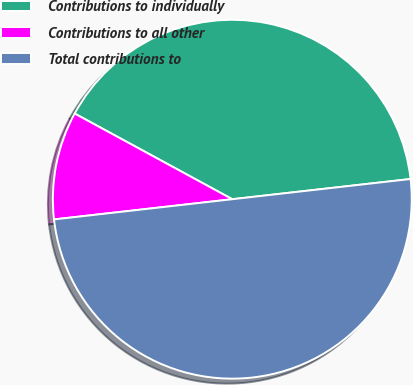Convert chart. <chart><loc_0><loc_0><loc_500><loc_500><pie_chart><fcel>Contributions to individually<fcel>Contributions to all other<fcel>Total contributions to<nl><fcel>40.28%<fcel>9.72%<fcel>50.0%<nl></chart> 